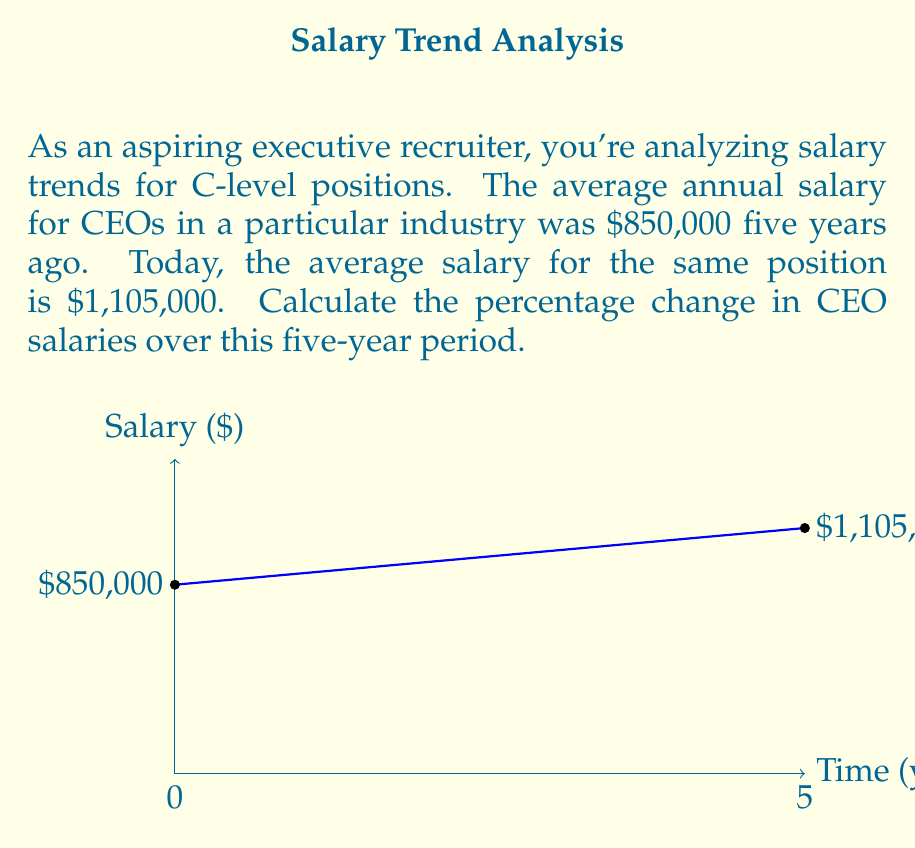Provide a solution to this math problem. To calculate the percentage change in CEO salaries, we'll use the following formula:

$$ \text{Percentage Change} = \frac{\text{New Value} - \text{Original Value}}{\text{Original Value}} \times 100\% $$

Let's plug in our values:

1) Original Value (5 years ago): $850,000
2) New Value (today): $1,105,000

$$ \text{Percentage Change} = \frac{1,105,000 - 850,000}{850,000} \times 100\% $$

$$ = \frac{255,000}{850,000} \times 100\% $$

$$ = 0.3 \times 100\% $$

$$ = 30\% $$

Therefore, the percentage change in CEO salaries over the five-year period is a 30% increase.
Answer: 30% increase 